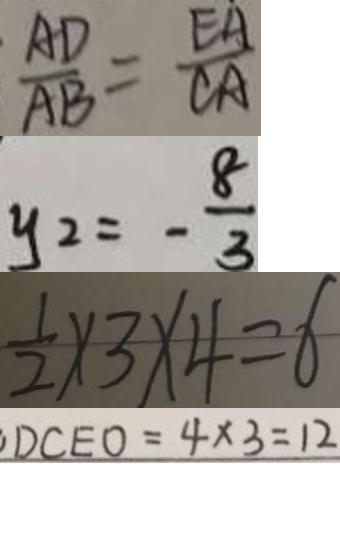Convert formula to latex. <formula><loc_0><loc_0><loc_500><loc_500>\frac { A D } { A B } = \frac { E A } { C A } 
 y _ { 2 } = - \frac { 8 } { 3 } 
 \frac { 1 } { 2 } \times 3 \times 4 = 6 
 D C E O = 4 \times 3 = 1 2</formula> 